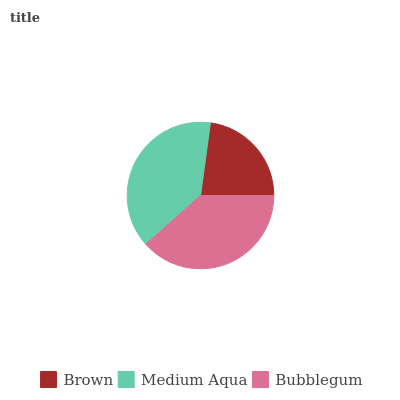Is Brown the minimum?
Answer yes or no. Yes. Is Medium Aqua the maximum?
Answer yes or no. Yes. Is Bubblegum the minimum?
Answer yes or no. No. Is Bubblegum the maximum?
Answer yes or no. No. Is Medium Aqua greater than Bubblegum?
Answer yes or no. Yes. Is Bubblegum less than Medium Aqua?
Answer yes or no. Yes. Is Bubblegum greater than Medium Aqua?
Answer yes or no. No. Is Medium Aqua less than Bubblegum?
Answer yes or no. No. Is Bubblegum the high median?
Answer yes or no. Yes. Is Bubblegum the low median?
Answer yes or no. Yes. Is Medium Aqua the high median?
Answer yes or no. No. Is Brown the low median?
Answer yes or no. No. 